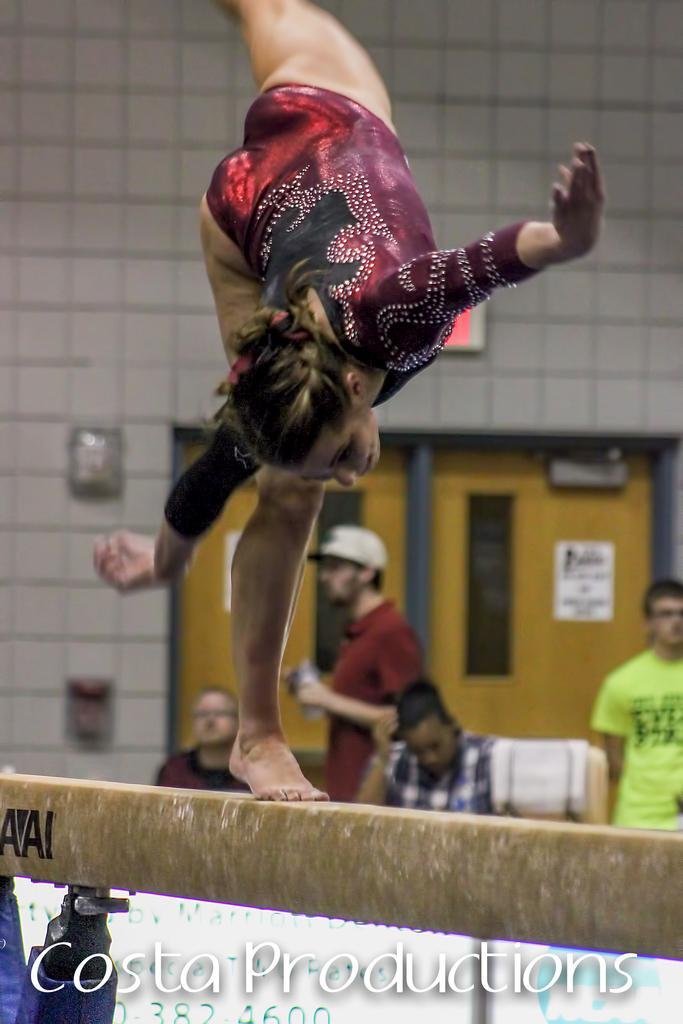Can you describe this image briefly? In the given image i can see a lady standing on the wooden object and behind her i can see a people,wall and some other objects. 